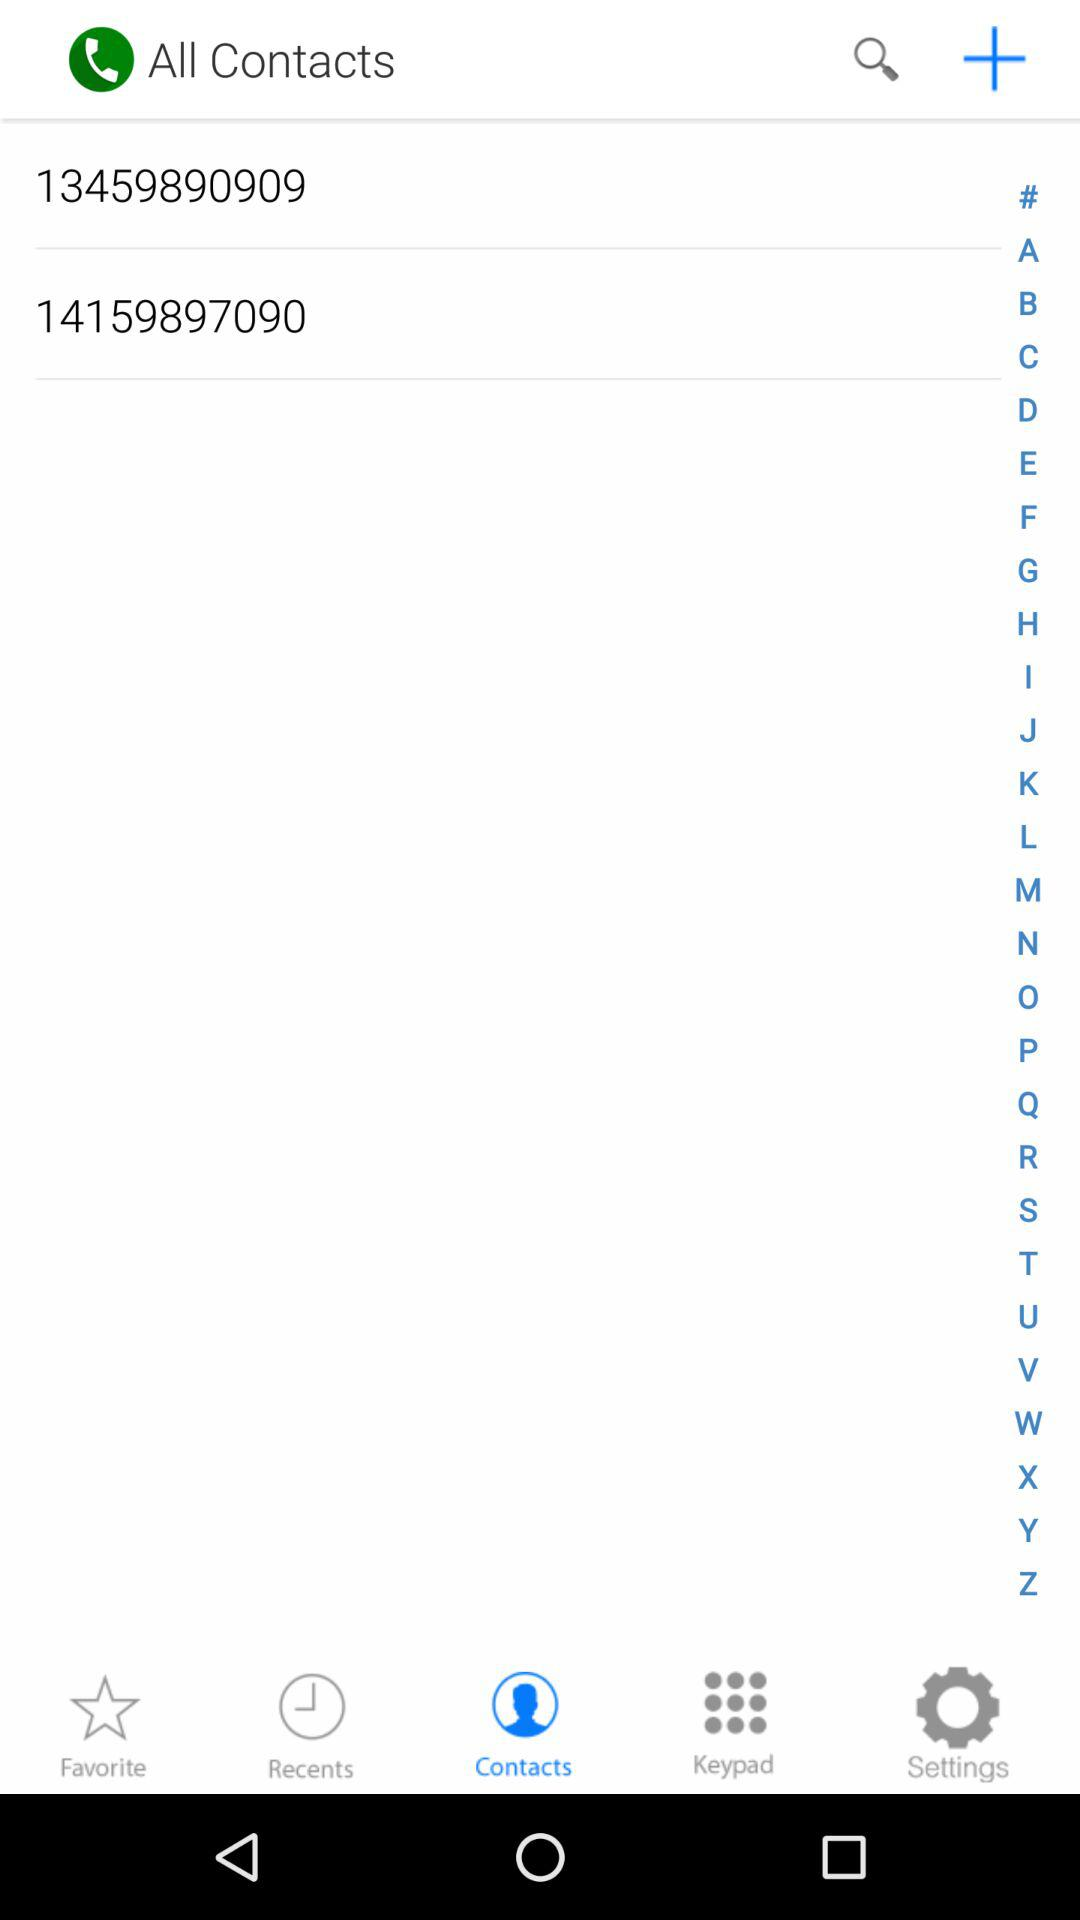What were the numbers in my contact list? The numbers in your contact list were 13459890909 and 14159897090. 